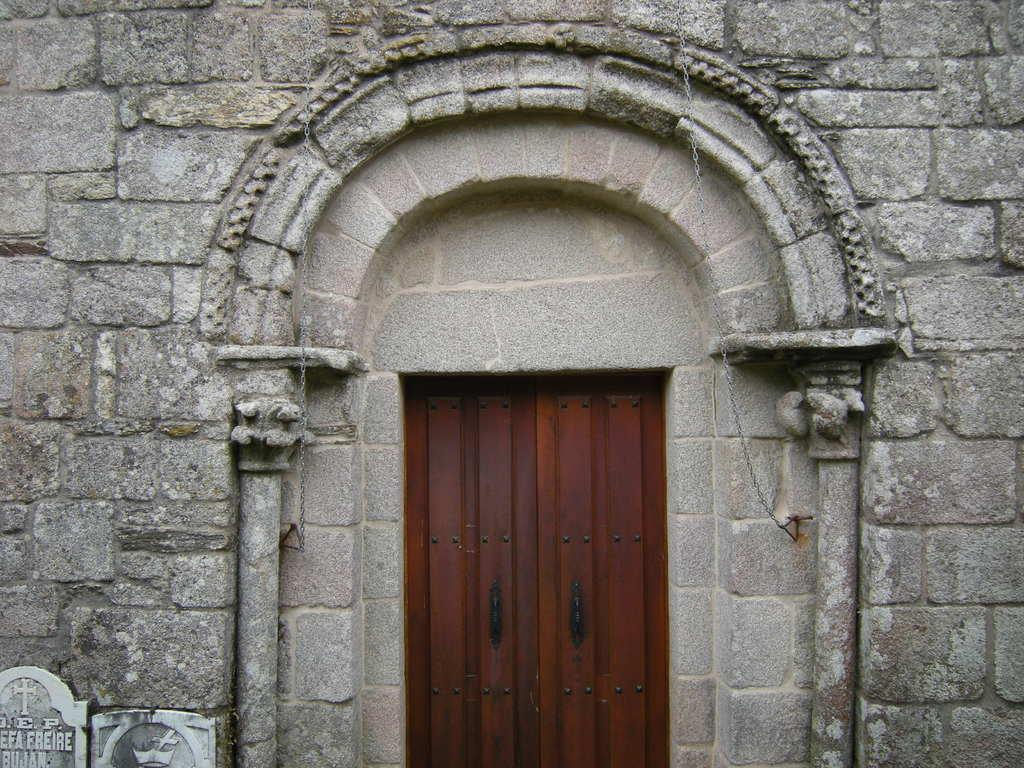What type of structure is the main subject in the image? There is a monumental building in the image. What feature of the building is mentioned in the facts? The building has doors. How many pies are being served in the image? There is no mention of pies or any food in the image; it features a monumental building with doors. 